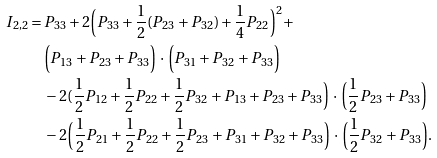<formula> <loc_0><loc_0><loc_500><loc_500>I _ { 2 , 2 } = & \, P _ { 3 3 } + 2 \Big ( P _ { 3 3 } + \frac { 1 } { 2 } ( P _ { 2 3 } + P _ { 3 2 } ) + \frac { 1 } { 4 } P _ { 2 2 } \Big ) ^ { 2 } + \\ & \, \Big ( P _ { 1 3 } + P _ { 2 3 } + P _ { 3 3 } \Big ) \, \cdot \, \Big ( P _ { 3 1 } + P _ { 3 2 } + P _ { 3 3 } \Big ) \\ & \, - 2 ( \frac { 1 } { 2 } P _ { 1 2 } + \frac { 1 } { 2 } P _ { 2 2 } + \frac { 1 } { 2 } P _ { 3 2 } + P _ { 1 3 } + P _ { 2 3 } + P _ { 3 3 } \Big ) \, \cdot \, \Big ( \frac { 1 } { 2 } P _ { 2 3 } + P _ { 3 3 } \Big ) \\ & \, - 2 \Big ( \frac { 1 } { 2 } P _ { 2 1 } + \frac { 1 } { 2 } P _ { 2 2 } + \frac { 1 } { 2 } P _ { 2 3 } + P _ { 3 1 } + P _ { 3 2 } + P _ { 3 3 } \Big ) \, \cdot \, \Big ( \frac { 1 } { 2 } P _ { 3 2 } + P _ { 3 3 } \Big ) .</formula> 